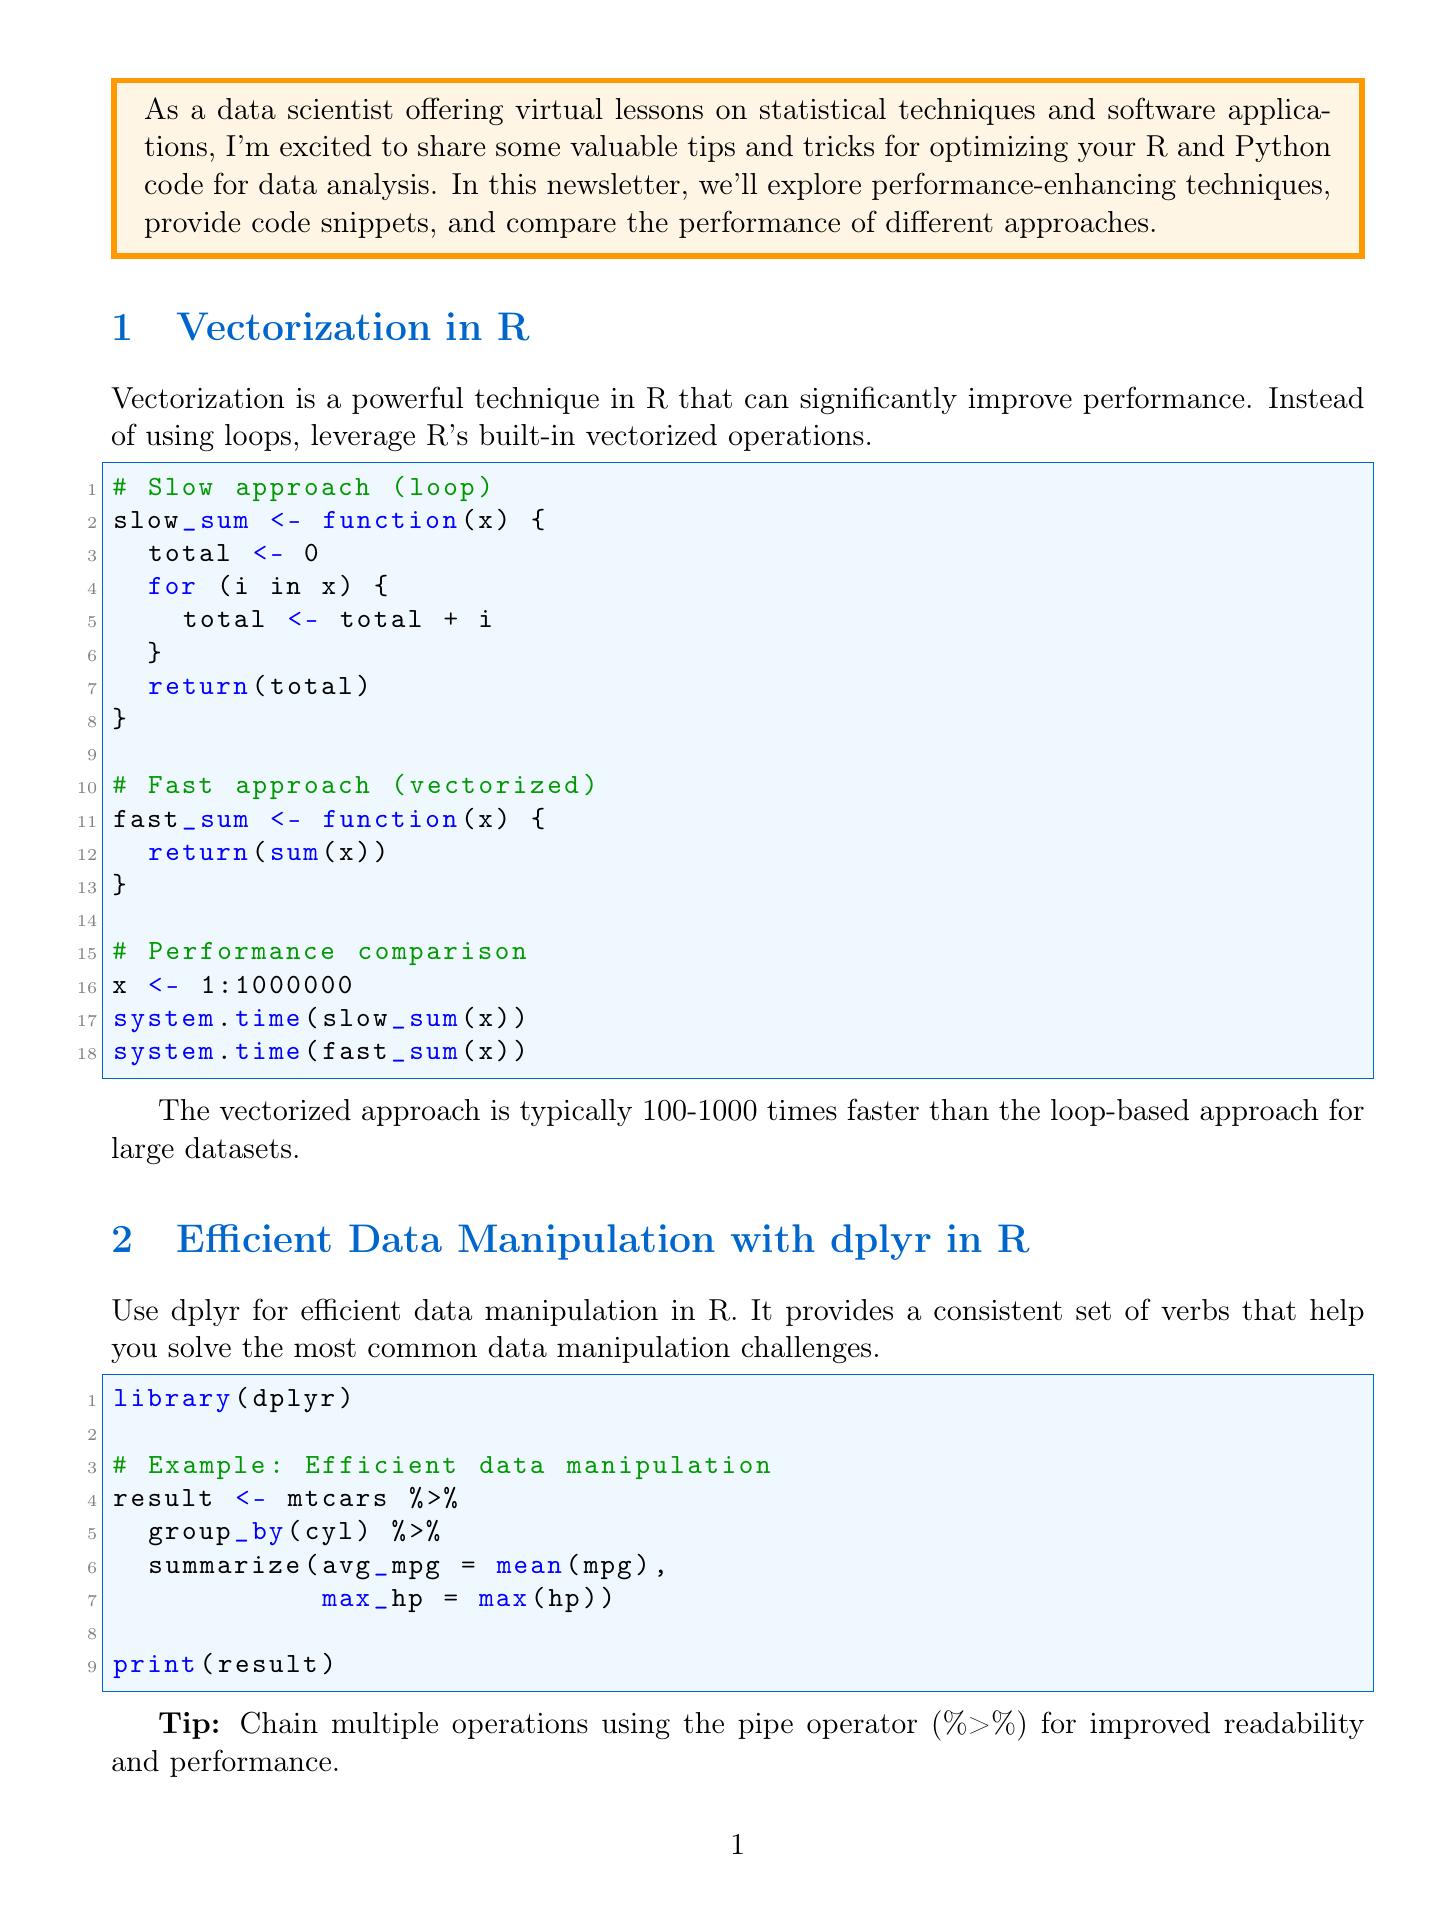What is the title of the newsletter? The title is stated at the beginning of the newsletter.
Answer: Optimize Your Data Analysis: R and Python Performance Boosters What technique can improve performance in R? The document mentions a specific technique for R optimization.
Answer: Vectorization Which library is recommended for efficient data manipulation in R? The newsletter suggests a specific library designed for R.
Answer: dplyr What is the performance comparison of vectorized approach vs. loop-based approach? The document provides a speed comparison between two programming approaches for performance in R.
Answer: 100-1000 times faster How much faster can the query method be compared to traditional boolean indexing in Pandas? The newsletter contains a specific performance improvement measurement for a method in Pandas.
Answer: 2-3 times faster What is a key benefit of using NumPy broadcasting? The document highlights an advantage of a specific technique used in Python.
Answer: Eliminates explicit loops What is the suggested use case for Python's multiprocessing module? The text describes a specific situation where a Python module can be applied efficiently.
Answer: CPU-bound tasks What should you focus on when profiling your code? The conclusion gives advice on profiling code for performance optimization.
Answer: Most time-consuming parts 